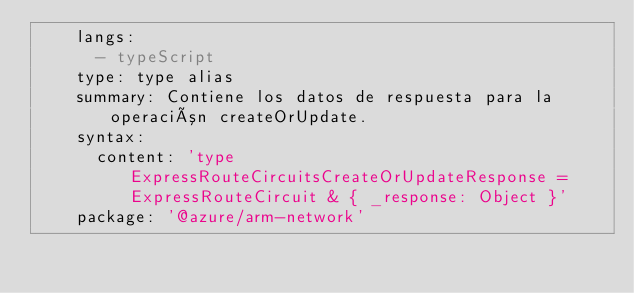Convert code to text. <code><loc_0><loc_0><loc_500><loc_500><_YAML_>    langs:
      - typeScript
    type: type alias
    summary: Contiene los datos de respuesta para la operación createOrUpdate.
    syntax:
      content: 'type ExpressRouteCircuitsCreateOrUpdateResponse = ExpressRouteCircuit & { _response: Object }'
    package: '@azure/arm-network'</code> 